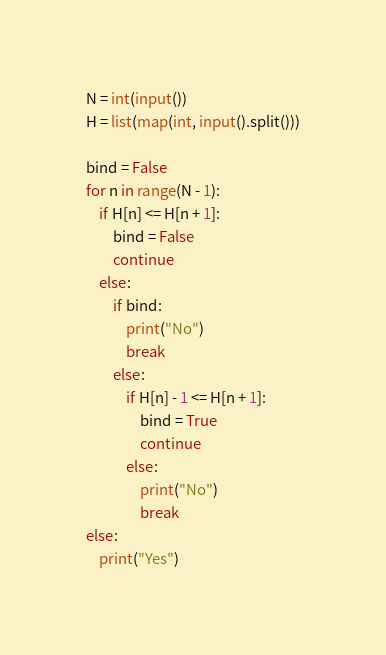<code> <loc_0><loc_0><loc_500><loc_500><_Python_>N = int(input())
H = list(map(int, input().split()))

bind = False
for n in range(N - 1):
	if H[n] <= H[n + 1]:
		bind = False
		continue
	else:
		if bind:
			print("No")
			break
		else:
			if H[n] - 1 <= H[n + 1]:
				bind = True
				continue
			else:
				print("No")
				break
else:
	print("Yes")
</code> 